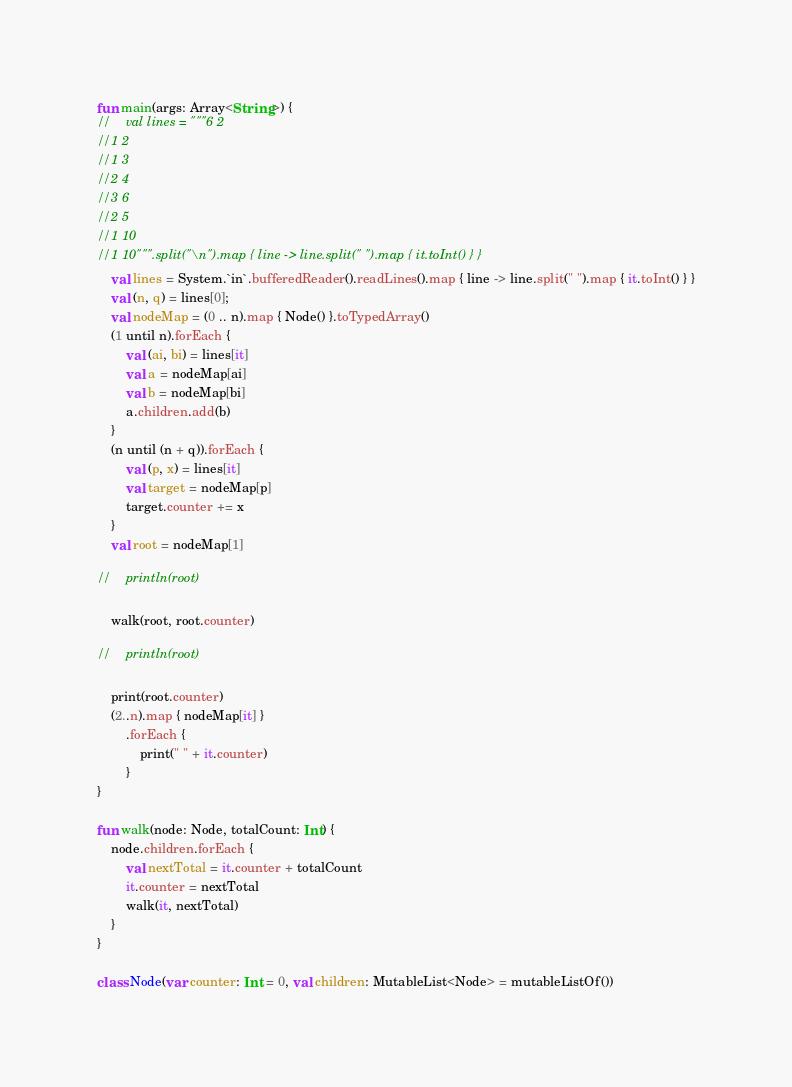Convert code to text. <code><loc_0><loc_0><loc_500><loc_500><_Kotlin_>fun main(args: Array<String>) {
//    val lines = """6 2
//1 2
//1 3
//2 4
//3 6
//2 5
//1 10
//1 10""".split("\n").map { line -> line.split(" ").map { it.toInt() } }
    val lines = System.`in`.bufferedReader().readLines().map { line -> line.split(" ").map { it.toInt() } }
    val (n, q) = lines[0];
    val nodeMap = (0 .. n).map { Node() }.toTypedArray()
    (1 until n).forEach {
        val (ai, bi) = lines[it]
        val a = nodeMap[ai]
        val b = nodeMap[bi]
        a.children.add(b)
    }
    (n until (n + q)).forEach {
        val (p, x) = lines[it]
        val target = nodeMap[p]
        target.counter += x
    }
    val root = nodeMap[1]

//    println(root)

    walk(root, root.counter)

//    println(root)

    print(root.counter)
    (2..n).map { nodeMap[it] }
        .forEach {
            print(" " + it.counter)
        }
}

fun walk(node: Node, totalCount: Int) {
    node.children.forEach {
        val nextTotal = it.counter + totalCount
        it.counter = nextTotal
        walk(it, nextTotal)
    }
}

class Node(var counter: Int = 0, val children: MutableList<Node> = mutableListOf())
</code> 